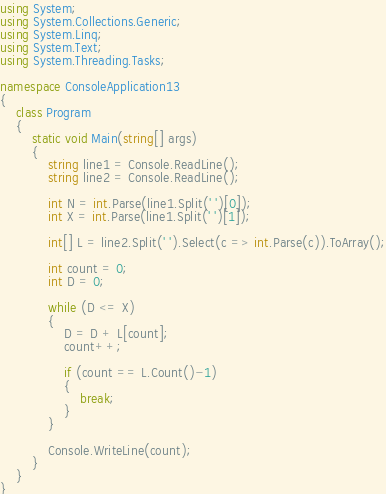<code> <loc_0><loc_0><loc_500><loc_500><_C#_>using System;
using System.Collections.Generic;
using System.Linq;
using System.Text;
using System.Threading.Tasks;

namespace ConsoleApplication13
{
    class Program
    {
        static void Main(string[] args)
        {
            string line1 = Console.ReadLine();
            string line2 = Console.ReadLine();

            int N = int.Parse(line1.Split(' ')[0]);
            int X = int.Parse(line1.Split(' ')[1]);

            int[] L = line2.Split(' ').Select(c => int.Parse(c)).ToArray();

            int count = 0;
            int D = 0;

            while (D <= X)
            {
                D = D + L[count];
                count++;

                if (count == L.Count()-1)
                {
                    break;
                }
            }

            Console.WriteLine(count);
        }
    }
}
</code> 